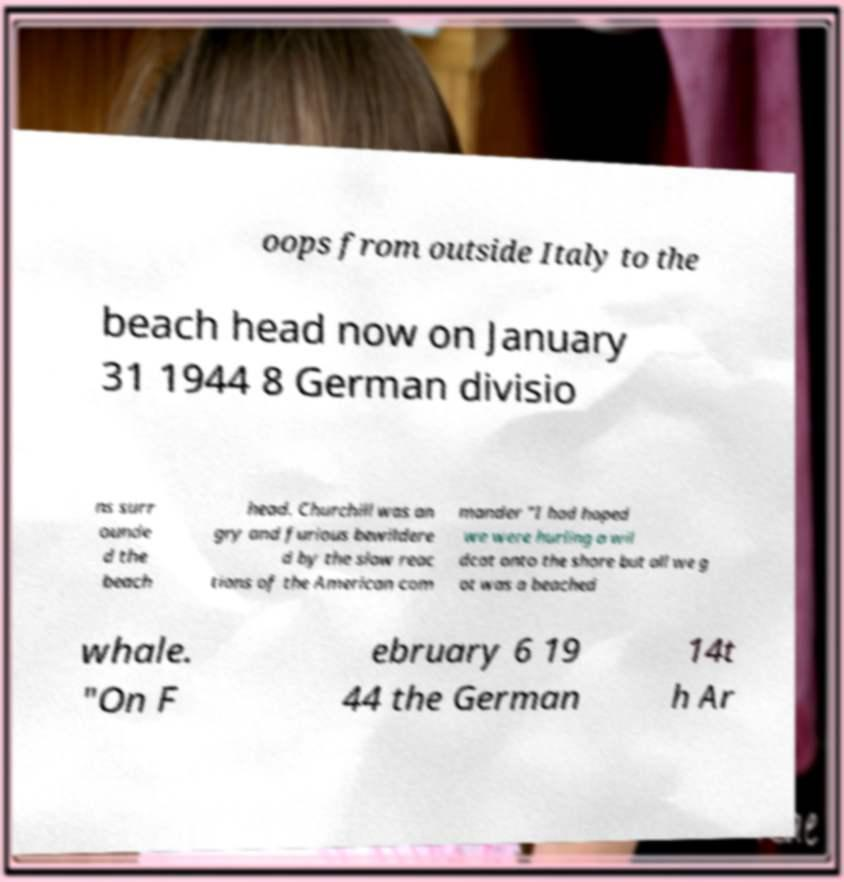Could you assist in decoding the text presented in this image and type it out clearly? oops from outside Italy to the beach head now on January 31 1944 8 German divisio ns surr ounde d the beach head. Churchill was an gry and furious bewildere d by the slow reac tions of the American com mander "I had hoped we were hurling a wil dcat onto the shore but all we g ot was a beached whale. "On F ebruary 6 19 44 the German 14t h Ar 